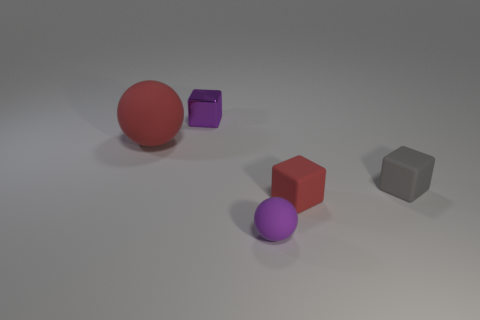Are there any other things that are made of the same material as the tiny purple cube?
Make the answer very short. No. What material is the small purple object that is the same shape as the tiny red matte object?
Your response must be concise. Metal. The small purple object in front of the metal object that is to the left of the small purple object right of the shiny block is made of what material?
Make the answer very short. Rubber. Does the red cube have the same material as the purple cube?
Provide a succinct answer. No. There is a tiny object that is the same color as the large ball; what is its shape?
Provide a succinct answer. Cube. There is a sphere that is in front of the large red thing; is its color the same as the metallic object?
Your response must be concise. Yes. What color is the ball that is the same size as the purple metallic cube?
Give a very brief answer. Purple. What is the tiny purple object that is behind the small purple ball made of?
Keep it short and to the point. Metal. The thing that is on the right side of the red ball and behind the small gray thing is made of what material?
Provide a short and direct response. Metal. Is the size of the purple object that is behind the purple rubber ball the same as the gray matte block?
Provide a short and direct response. Yes. 